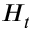Convert formula to latex. <formula><loc_0><loc_0><loc_500><loc_500>H _ { t }</formula> 